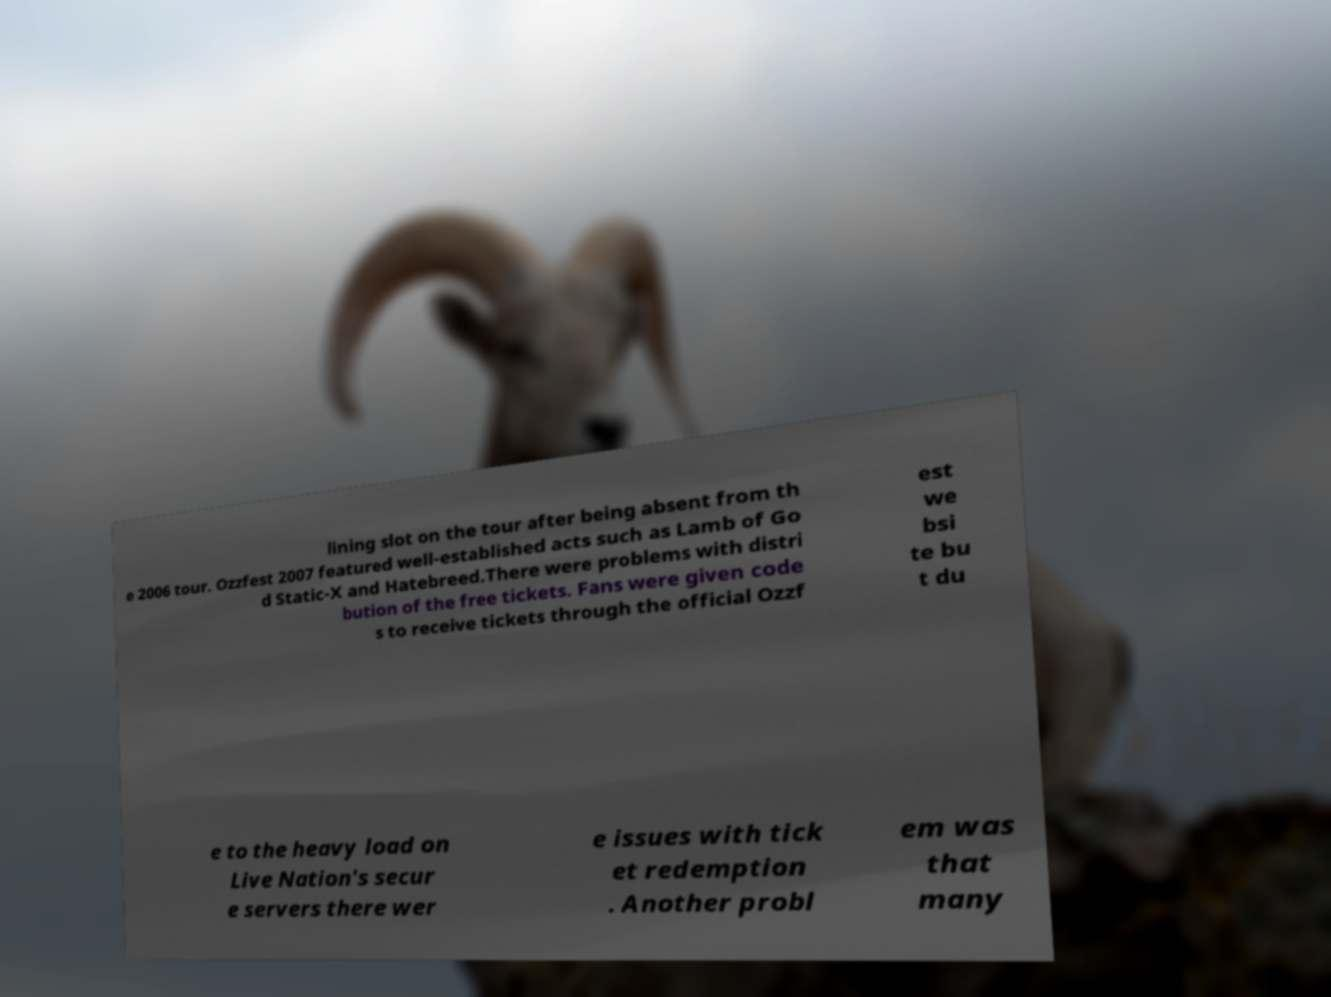Can you read and provide the text displayed in the image?This photo seems to have some interesting text. Can you extract and type it out for me? lining slot on the tour after being absent from th e 2006 tour. Ozzfest 2007 featured well-established acts such as Lamb of Go d Static-X and Hatebreed.There were problems with distri bution of the free tickets. Fans were given code s to receive tickets through the official Ozzf est we bsi te bu t du e to the heavy load on Live Nation's secur e servers there wer e issues with tick et redemption . Another probl em was that many 